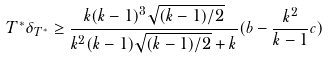<formula> <loc_0><loc_0><loc_500><loc_500>T ^ { * } \delta _ { T ^ { * } } \geq \frac { k ( k - 1 ) ^ { 3 } \sqrt { ( k - 1 ) / 2 } } { k ^ { 2 } ( k - 1 ) \sqrt { ( k - 1 ) / 2 } + k } ( b - \frac { k ^ { 2 } } { k - 1 } c )</formula> 